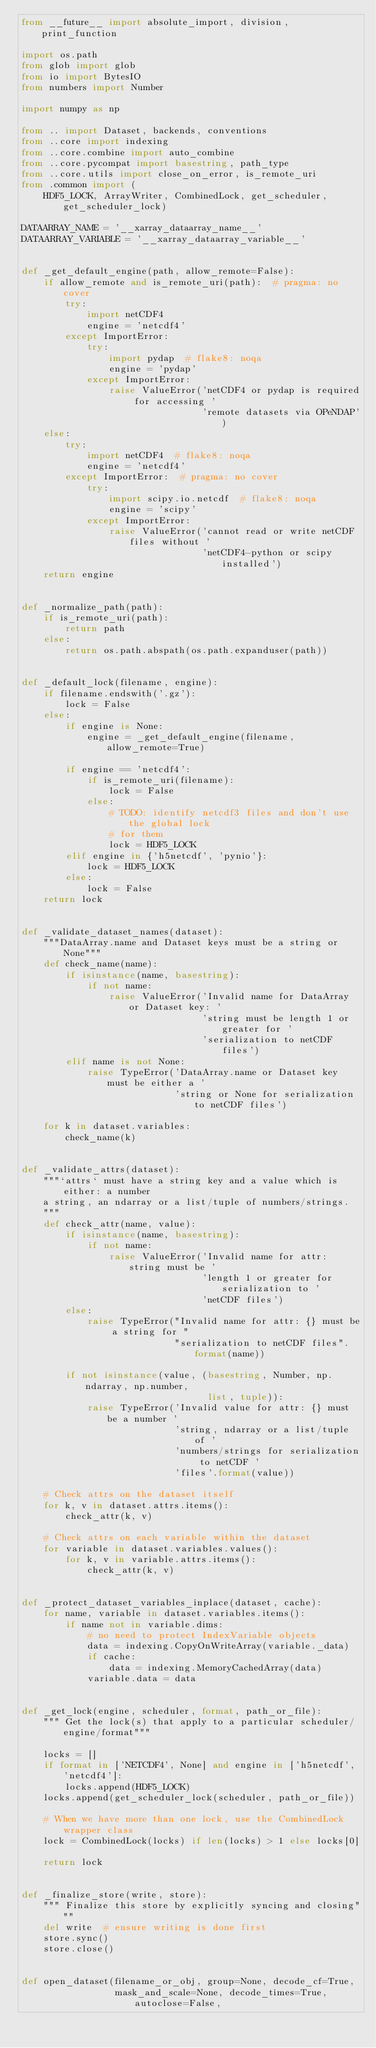Convert code to text. <code><loc_0><loc_0><loc_500><loc_500><_Python_>from __future__ import absolute_import, division, print_function

import os.path
from glob import glob
from io import BytesIO
from numbers import Number

import numpy as np

from .. import Dataset, backends, conventions
from ..core import indexing
from ..core.combine import auto_combine
from ..core.pycompat import basestring, path_type
from ..core.utils import close_on_error, is_remote_uri
from .common import (
    HDF5_LOCK, ArrayWriter, CombinedLock, get_scheduler, get_scheduler_lock)

DATAARRAY_NAME = '__xarray_dataarray_name__'
DATAARRAY_VARIABLE = '__xarray_dataarray_variable__'


def _get_default_engine(path, allow_remote=False):
    if allow_remote and is_remote_uri(path):  # pragma: no cover
        try:
            import netCDF4
            engine = 'netcdf4'
        except ImportError:
            try:
                import pydap  # flake8: noqa
                engine = 'pydap'
            except ImportError:
                raise ValueError('netCDF4 or pydap is required for accessing '
                                 'remote datasets via OPeNDAP')
    else:
        try:
            import netCDF4  # flake8: noqa
            engine = 'netcdf4'
        except ImportError:  # pragma: no cover
            try:
                import scipy.io.netcdf  # flake8: noqa
                engine = 'scipy'
            except ImportError:
                raise ValueError('cannot read or write netCDF files without '
                                 'netCDF4-python or scipy installed')
    return engine


def _normalize_path(path):
    if is_remote_uri(path):
        return path
    else:
        return os.path.abspath(os.path.expanduser(path))


def _default_lock(filename, engine):
    if filename.endswith('.gz'):
        lock = False
    else:
        if engine is None:
            engine = _get_default_engine(filename, allow_remote=True)

        if engine == 'netcdf4':
            if is_remote_uri(filename):
                lock = False
            else:
                # TODO: identify netcdf3 files and don't use the global lock
                # for them
                lock = HDF5_LOCK
        elif engine in {'h5netcdf', 'pynio'}:
            lock = HDF5_LOCK
        else:
            lock = False
    return lock


def _validate_dataset_names(dataset):
    """DataArray.name and Dataset keys must be a string or None"""
    def check_name(name):
        if isinstance(name, basestring):
            if not name:
                raise ValueError('Invalid name for DataArray or Dataset key: '
                                 'string must be length 1 or greater for '
                                 'serialization to netCDF files')
        elif name is not None:
            raise TypeError('DataArray.name or Dataset key must be either a '
                            'string or None for serialization to netCDF files')

    for k in dataset.variables:
        check_name(k)


def _validate_attrs(dataset):
    """`attrs` must have a string key and a value which is either: a number
    a string, an ndarray or a list/tuple of numbers/strings.
    """
    def check_attr(name, value):
        if isinstance(name, basestring):
            if not name:
                raise ValueError('Invalid name for attr: string must be '
                                 'length 1 or greater for serialization to '
                                 'netCDF files')
        else:
            raise TypeError("Invalid name for attr: {} must be a string for "
                            "serialization to netCDF files".format(name))

        if not isinstance(value, (basestring, Number, np.ndarray, np.number,
                                  list, tuple)):
            raise TypeError('Invalid value for attr: {} must be a number '
                            'string, ndarray or a list/tuple of '
                            'numbers/strings for serialization to netCDF '
                            'files'.format(value))

    # Check attrs on the dataset itself
    for k, v in dataset.attrs.items():
        check_attr(k, v)

    # Check attrs on each variable within the dataset
    for variable in dataset.variables.values():
        for k, v in variable.attrs.items():
            check_attr(k, v)


def _protect_dataset_variables_inplace(dataset, cache):
    for name, variable in dataset.variables.items():
        if name not in variable.dims:
            # no need to protect IndexVariable objects
            data = indexing.CopyOnWriteArray(variable._data)
            if cache:
                data = indexing.MemoryCachedArray(data)
            variable.data = data


def _get_lock(engine, scheduler, format, path_or_file):
    """ Get the lock(s) that apply to a particular scheduler/engine/format"""

    locks = []
    if format in ['NETCDF4', None] and engine in ['h5netcdf', 'netcdf4']:
        locks.append(HDF5_LOCK)
    locks.append(get_scheduler_lock(scheduler, path_or_file))

    # When we have more than one lock, use the CombinedLock wrapper class
    lock = CombinedLock(locks) if len(locks) > 1 else locks[0]

    return lock


def _finalize_store(write, store):
    """ Finalize this store by explicitly syncing and closing"""
    del write  # ensure writing is done first
    store.sync()
    store.close()


def open_dataset(filename_or_obj, group=None, decode_cf=True,
                 mask_and_scale=None, decode_times=True, autoclose=False,</code> 